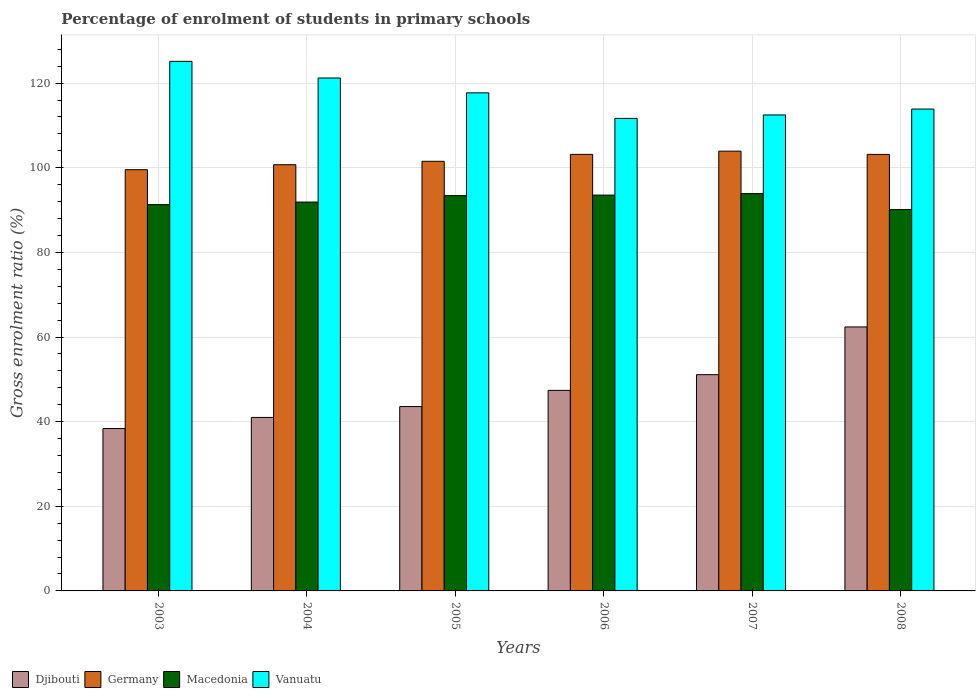How many groups of bars are there?
Your answer should be very brief. 6. Are the number of bars per tick equal to the number of legend labels?
Offer a very short reply. Yes. Are the number of bars on each tick of the X-axis equal?
Provide a short and direct response. Yes. How many bars are there on the 1st tick from the left?
Give a very brief answer. 4. How many bars are there on the 5th tick from the right?
Your response must be concise. 4. In how many cases, is the number of bars for a given year not equal to the number of legend labels?
Your answer should be compact. 0. What is the percentage of students enrolled in primary schools in Djibouti in 2003?
Make the answer very short. 38.37. Across all years, what is the maximum percentage of students enrolled in primary schools in Macedonia?
Provide a succinct answer. 93.9. Across all years, what is the minimum percentage of students enrolled in primary schools in Djibouti?
Give a very brief answer. 38.37. In which year was the percentage of students enrolled in primary schools in Vanuatu minimum?
Your answer should be compact. 2006. What is the total percentage of students enrolled in primary schools in Djibouti in the graph?
Make the answer very short. 283.82. What is the difference between the percentage of students enrolled in primary schools in Vanuatu in 2003 and that in 2008?
Provide a short and direct response. 11.27. What is the difference between the percentage of students enrolled in primary schools in Vanuatu in 2008 and the percentage of students enrolled in primary schools in Macedonia in 2006?
Your answer should be very brief. 20.33. What is the average percentage of students enrolled in primary schools in Germany per year?
Your response must be concise. 102.01. In the year 2003, what is the difference between the percentage of students enrolled in primary schools in Macedonia and percentage of students enrolled in primary schools in Germany?
Give a very brief answer. -8.25. In how many years, is the percentage of students enrolled in primary schools in Djibouti greater than 100 %?
Make the answer very short. 0. What is the ratio of the percentage of students enrolled in primary schools in Vanuatu in 2004 to that in 2005?
Offer a very short reply. 1.03. What is the difference between the highest and the second highest percentage of students enrolled in primary schools in Vanuatu?
Your response must be concise. 3.93. What is the difference between the highest and the lowest percentage of students enrolled in primary schools in Germany?
Ensure brevity in your answer.  4.39. Is it the case that in every year, the sum of the percentage of students enrolled in primary schools in Macedonia and percentage of students enrolled in primary schools in Germany is greater than the sum of percentage of students enrolled in primary schools in Vanuatu and percentage of students enrolled in primary schools in Djibouti?
Offer a terse response. No. What does the 1st bar from the left in 2007 represents?
Your answer should be compact. Djibouti. What does the 1st bar from the right in 2003 represents?
Your answer should be very brief. Vanuatu. How many bars are there?
Your response must be concise. 24. Are all the bars in the graph horizontal?
Keep it short and to the point. No. Does the graph contain any zero values?
Your answer should be very brief. No. Does the graph contain grids?
Your answer should be compact. Yes. How are the legend labels stacked?
Your answer should be compact. Horizontal. What is the title of the graph?
Offer a very short reply. Percentage of enrolment of students in primary schools. What is the Gross enrolment ratio (%) of Djibouti in 2003?
Your answer should be compact. 38.37. What is the Gross enrolment ratio (%) of Germany in 2003?
Provide a succinct answer. 99.54. What is the Gross enrolment ratio (%) of Macedonia in 2003?
Make the answer very short. 91.29. What is the Gross enrolment ratio (%) of Vanuatu in 2003?
Keep it short and to the point. 125.15. What is the Gross enrolment ratio (%) of Djibouti in 2004?
Your answer should be very brief. 41. What is the Gross enrolment ratio (%) in Germany in 2004?
Make the answer very short. 100.72. What is the Gross enrolment ratio (%) in Macedonia in 2004?
Your answer should be compact. 91.9. What is the Gross enrolment ratio (%) of Vanuatu in 2004?
Provide a short and direct response. 121.22. What is the Gross enrolment ratio (%) in Djibouti in 2005?
Provide a short and direct response. 43.57. What is the Gross enrolment ratio (%) of Germany in 2005?
Keep it short and to the point. 101.53. What is the Gross enrolment ratio (%) of Macedonia in 2005?
Offer a terse response. 93.42. What is the Gross enrolment ratio (%) in Vanuatu in 2005?
Provide a short and direct response. 117.71. What is the Gross enrolment ratio (%) in Djibouti in 2006?
Offer a very short reply. 47.39. What is the Gross enrolment ratio (%) in Germany in 2006?
Keep it short and to the point. 103.17. What is the Gross enrolment ratio (%) in Macedonia in 2006?
Offer a terse response. 93.54. What is the Gross enrolment ratio (%) in Vanuatu in 2006?
Ensure brevity in your answer.  111.67. What is the Gross enrolment ratio (%) of Djibouti in 2007?
Keep it short and to the point. 51.1. What is the Gross enrolment ratio (%) of Germany in 2007?
Offer a terse response. 103.93. What is the Gross enrolment ratio (%) of Macedonia in 2007?
Keep it short and to the point. 93.9. What is the Gross enrolment ratio (%) in Vanuatu in 2007?
Your answer should be compact. 112.48. What is the Gross enrolment ratio (%) of Djibouti in 2008?
Your answer should be very brief. 62.38. What is the Gross enrolment ratio (%) in Germany in 2008?
Your answer should be compact. 103.16. What is the Gross enrolment ratio (%) in Macedonia in 2008?
Your answer should be very brief. 90.13. What is the Gross enrolment ratio (%) of Vanuatu in 2008?
Your answer should be compact. 113.87. Across all years, what is the maximum Gross enrolment ratio (%) in Djibouti?
Make the answer very short. 62.38. Across all years, what is the maximum Gross enrolment ratio (%) of Germany?
Your answer should be compact. 103.93. Across all years, what is the maximum Gross enrolment ratio (%) of Macedonia?
Offer a terse response. 93.9. Across all years, what is the maximum Gross enrolment ratio (%) of Vanuatu?
Your answer should be compact. 125.15. Across all years, what is the minimum Gross enrolment ratio (%) in Djibouti?
Your answer should be compact. 38.37. Across all years, what is the minimum Gross enrolment ratio (%) of Germany?
Give a very brief answer. 99.54. Across all years, what is the minimum Gross enrolment ratio (%) of Macedonia?
Keep it short and to the point. 90.13. Across all years, what is the minimum Gross enrolment ratio (%) in Vanuatu?
Ensure brevity in your answer.  111.67. What is the total Gross enrolment ratio (%) in Djibouti in the graph?
Make the answer very short. 283.82. What is the total Gross enrolment ratio (%) in Germany in the graph?
Your answer should be compact. 612.04. What is the total Gross enrolment ratio (%) of Macedonia in the graph?
Ensure brevity in your answer.  554.17. What is the total Gross enrolment ratio (%) in Vanuatu in the graph?
Ensure brevity in your answer.  702.1. What is the difference between the Gross enrolment ratio (%) of Djibouti in 2003 and that in 2004?
Your answer should be compact. -2.63. What is the difference between the Gross enrolment ratio (%) of Germany in 2003 and that in 2004?
Offer a terse response. -1.18. What is the difference between the Gross enrolment ratio (%) in Macedonia in 2003 and that in 2004?
Your answer should be very brief. -0.61. What is the difference between the Gross enrolment ratio (%) of Vanuatu in 2003 and that in 2004?
Give a very brief answer. 3.93. What is the difference between the Gross enrolment ratio (%) in Djibouti in 2003 and that in 2005?
Your answer should be compact. -5.19. What is the difference between the Gross enrolment ratio (%) in Germany in 2003 and that in 2005?
Provide a succinct answer. -1.99. What is the difference between the Gross enrolment ratio (%) of Macedonia in 2003 and that in 2005?
Your answer should be very brief. -2.13. What is the difference between the Gross enrolment ratio (%) in Vanuatu in 2003 and that in 2005?
Give a very brief answer. 7.44. What is the difference between the Gross enrolment ratio (%) of Djibouti in 2003 and that in 2006?
Your answer should be very brief. -9.02. What is the difference between the Gross enrolment ratio (%) in Germany in 2003 and that in 2006?
Offer a very short reply. -3.63. What is the difference between the Gross enrolment ratio (%) in Macedonia in 2003 and that in 2006?
Make the answer very short. -2.25. What is the difference between the Gross enrolment ratio (%) in Vanuatu in 2003 and that in 2006?
Your answer should be compact. 13.48. What is the difference between the Gross enrolment ratio (%) in Djibouti in 2003 and that in 2007?
Provide a short and direct response. -12.73. What is the difference between the Gross enrolment ratio (%) of Germany in 2003 and that in 2007?
Your answer should be very brief. -4.39. What is the difference between the Gross enrolment ratio (%) of Macedonia in 2003 and that in 2007?
Provide a short and direct response. -2.61. What is the difference between the Gross enrolment ratio (%) of Vanuatu in 2003 and that in 2007?
Offer a very short reply. 12.66. What is the difference between the Gross enrolment ratio (%) of Djibouti in 2003 and that in 2008?
Your response must be concise. -24.01. What is the difference between the Gross enrolment ratio (%) of Germany in 2003 and that in 2008?
Offer a terse response. -3.62. What is the difference between the Gross enrolment ratio (%) in Macedonia in 2003 and that in 2008?
Offer a very short reply. 1.16. What is the difference between the Gross enrolment ratio (%) in Vanuatu in 2003 and that in 2008?
Your answer should be compact. 11.27. What is the difference between the Gross enrolment ratio (%) in Djibouti in 2004 and that in 2005?
Give a very brief answer. -2.57. What is the difference between the Gross enrolment ratio (%) in Germany in 2004 and that in 2005?
Ensure brevity in your answer.  -0.81. What is the difference between the Gross enrolment ratio (%) of Macedonia in 2004 and that in 2005?
Offer a very short reply. -1.52. What is the difference between the Gross enrolment ratio (%) of Vanuatu in 2004 and that in 2005?
Offer a terse response. 3.51. What is the difference between the Gross enrolment ratio (%) of Djibouti in 2004 and that in 2006?
Your answer should be very brief. -6.39. What is the difference between the Gross enrolment ratio (%) of Germany in 2004 and that in 2006?
Your answer should be very brief. -2.45. What is the difference between the Gross enrolment ratio (%) of Macedonia in 2004 and that in 2006?
Provide a succinct answer. -1.64. What is the difference between the Gross enrolment ratio (%) in Vanuatu in 2004 and that in 2006?
Provide a succinct answer. 9.55. What is the difference between the Gross enrolment ratio (%) in Djibouti in 2004 and that in 2007?
Give a very brief answer. -10.1. What is the difference between the Gross enrolment ratio (%) in Germany in 2004 and that in 2007?
Provide a short and direct response. -3.21. What is the difference between the Gross enrolment ratio (%) in Macedonia in 2004 and that in 2007?
Your answer should be very brief. -2. What is the difference between the Gross enrolment ratio (%) of Vanuatu in 2004 and that in 2007?
Make the answer very short. 8.73. What is the difference between the Gross enrolment ratio (%) of Djibouti in 2004 and that in 2008?
Ensure brevity in your answer.  -21.38. What is the difference between the Gross enrolment ratio (%) in Germany in 2004 and that in 2008?
Ensure brevity in your answer.  -2.44. What is the difference between the Gross enrolment ratio (%) in Macedonia in 2004 and that in 2008?
Give a very brief answer. 1.77. What is the difference between the Gross enrolment ratio (%) in Vanuatu in 2004 and that in 2008?
Keep it short and to the point. 7.34. What is the difference between the Gross enrolment ratio (%) in Djibouti in 2005 and that in 2006?
Your response must be concise. -3.83. What is the difference between the Gross enrolment ratio (%) of Germany in 2005 and that in 2006?
Give a very brief answer. -1.64. What is the difference between the Gross enrolment ratio (%) of Macedonia in 2005 and that in 2006?
Your answer should be compact. -0.13. What is the difference between the Gross enrolment ratio (%) in Vanuatu in 2005 and that in 2006?
Provide a short and direct response. 6.04. What is the difference between the Gross enrolment ratio (%) in Djibouti in 2005 and that in 2007?
Your answer should be very brief. -7.54. What is the difference between the Gross enrolment ratio (%) of Germany in 2005 and that in 2007?
Your answer should be compact. -2.4. What is the difference between the Gross enrolment ratio (%) in Macedonia in 2005 and that in 2007?
Your answer should be very brief. -0.48. What is the difference between the Gross enrolment ratio (%) of Vanuatu in 2005 and that in 2007?
Provide a succinct answer. 5.22. What is the difference between the Gross enrolment ratio (%) in Djibouti in 2005 and that in 2008?
Ensure brevity in your answer.  -18.82. What is the difference between the Gross enrolment ratio (%) of Germany in 2005 and that in 2008?
Offer a terse response. -1.63. What is the difference between the Gross enrolment ratio (%) of Macedonia in 2005 and that in 2008?
Give a very brief answer. 3.29. What is the difference between the Gross enrolment ratio (%) in Vanuatu in 2005 and that in 2008?
Give a very brief answer. 3.83. What is the difference between the Gross enrolment ratio (%) of Djibouti in 2006 and that in 2007?
Provide a short and direct response. -3.71. What is the difference between the Gross enrolment ratio (%) in Germany in 2006 and that in 2007?
Ensure brevity in your answer.  -0.76. What is the difference between the Gross enrolment ratio (%) of Macedonia in 2006 and that in 2007?
Provide a succinct answer. -0.35. What is the difference between the Gross enrolment ratio (%) of Vanuatu in 2006 and that in 2007?
Keep it short and to the point. -0.82. What is the difference between the Gross enrolment ratio (%) of Djibouti in 2006 and that in 2008?
Your answer should be compact. -14.99. What is the difference between the Gross enrolment ratio (%) of Germany in 2006 and that in 2008?
Keep it short and to the point. 0.01. What is the difference between the Gross enrolment ratio (%) of Macedonia in 2006 and that in 2008?
Ensure brevity in your answer.  3.42. What is the difference between the Gross enrolment ratio (%) of Vanuatu in 2006 and that in 2008?
Provide a succinct answer. -2.21. What is the difference between the Gross enrolment ratio (%) of Djibouti in 2007 and that in 2008?
Ensure brevity in your answer.  -11.28. What is the difference between the Gross enrolment ratio (%) in Germany in 2007 and that in 2008?
Offer a terse response. 0.77. What is the difference between the Gross enrolment ratio (%) in Macedonia in 2007 and that in 2008?
Keep it short and to the point. 3.77. What is the difference between the Gross enrolment ratio (%) of Vanuatu in 2007 and that in 2008?
Offer a very short reply. -1.39. What is the difference between the Gross enrolment ratio (%) of Djibouti in 2003 and the Gross enrolment ratio (%) of Germany in 2004?
Your response must be concise. -62.35. What is the difference between the Gross enrolment ratio (%) of Djibouti in 2003 and the Gross enrolment ratio (%) of Macedonia in 2004?
Your answer should be compact. -53.53. What is the difference between the Gross enrolment ratio (%) of Djibouti in 2003 and the Gross enrolment ratio (%) of Vanuatu in 2004?
Provide a succinct answer. -82.84. What is the difference between the Gross enrolment ratio (%) in Germany in 2003 and the Gross enrolment ratio (%) in Macedonia in 2004?
Offer a terse response. 7.64. What is the difference between the Gross enrolment ratio (%) of Germany in 2003 and the Gross enrolment ratio (%) of Vanuatu in 2004?
Your answer should be very brief. -21.68. What is the difference between the Gross enrolment ratio (%) of Macedonia in 2003 and the Gross enrolment ratio (%) of Vanuatu in 2004?
Offer a very short reply. -29.93. What is the difference between the Gross enrolment ratio (%) in Djibouti in 2003 and the Gross enrolment ratio (%) in Germany in 2005?
Offer a very short reply. -63.15. What is the difference between the Gross enrolment ratio (%) of Djibouti in 2003 and the Gross enrolment ratio (%) of Macedonia in 2005?
Your answer should be compact. -55.04. What is the difference between the Gross enrolment ratio (%) in Djibouti in 2003 and the Gross enrolment ratio (%) in Vanuatu in 2005?
Your response must be concise. -79.33. What is the difference between the Gross enrolment ratio (%) of Germany in 2003 and the Gross enrolment ratio (%) of Macedonia in 2005?
Make the answer very short. 6.12. What is the difference between the Gross enrolment ratio (%) in Germany in 2003 and the Gross enrolment ratio (%) in Vanuatu in 2005?
Keep it short and to the point. -18.17. What is the difference between the Gross enrolment ratio (%) of Macedonia in 2003 and the Gross enrolment ratio (%) of Vanuatu in 2005?
Provide a short and direct response. -26.42. What is the difference between the Gross enrolment ratio (%) in Djibouti in 2003 and the Gross enrolment ratio (%) in Germany in 2006?
Ensure brevity in your answer.  -64.79. What is the difference between the Gross enrolment ratio (%) of Djibouti in 2003 and the Gross enrolment ratio (%) of Macedonia in 2006?
Ensure brevity in your answer.  -55.17. What is the difference between the Gross enrolment ratio (%) in Djibouti in 2003 and the Gross enrolment ratio (%) in Vanuatu in 2006?
Give a very brief answer. -73.29. What is the difference between the Gross enrolment ratio (%) of Germany in 2003 and the Gross enrolment ratio (%) of Macedonia in 2006?
Offer a very short reply. 6. What is the difference between the Gross enrolment ratio (%) of Germany in 2003 and the Gross enrolment ratio (%) of Vanuatu in 2006?
Your answer should be compact. -12.13. What is the difference between the Gross enrolment ratio (%) of Macedonia in 2003 and the Gross enrolment ratio (%) of Vanuatu in 2006?
Keep it short and to the point. -20.38. What is the difference between the Gross enrolment ratio (%) in Djibouti in 2003 and the Gross enrolment ratio (%) in Germany in 2007?
Provide a succinct answer. -65.55. What is the difference between the Gross enrolment ratio (%) of Djibouti in 2003 and the Gross enrolment ratio (%) of Macedonia in 2007?
Your response must be concise. -55.52. What is the difference between the Gross enrolment ratio (%) in Djibouti in 2003 and the Gross enrolment ratio (%) in Vanuatu in 2007?
Your answer should be very brief. -74.11. What is the difference between the Gross enrolment ratio (%) of Germany in 2003 and the Gross enrolment ratio (%) of Macedonia in 2007?
Provide a short and direct response. 5.64. What is the difference between the Gross enrolment ratio (%) in Germany in 2003 and the Gross enrolment ratio (%) in Vanuatu in 2007?
Offer a very short reply. -12.94. What is the difference between the Gross enrolment ratio (%) in Macedonia in 2003 and the Gross enrolment ratio (%) in Vanuatu in 2007?
Give a very brief answer. -21.2. What is the difference between the Gross enrolment ratio (%) in Djibouti in 2003 and the Gross enrolment ratio (%) in Germany in 2008?
Make the answer very short. -64.79. What is the difference between the Gross enrolment ratio (%) of Djibouti in 2003 and the Gross enrolment ratio (%) of Macedonia in 2008?
Your response must be concise. -51.75. What is the difference between the Gross enrolment ratio (%) of Djibouti in 2003 and the Gross enrolment ratio (%) of Vanuatu in 2008?
Your response must be concise. -75.5. What is the difference between the Gross enrolment ratio (%) in Germany in 2003 and the Gross enrolment ratio (%) in Macedonia in 2008?
Make the answer very short. 9.41. What is the difference between the Gross enrolment ratio (%) of Germany in 2003 and the Gross enrolment ratio (%) of Vanuatu in 2008?
Keep it short and to the point. -14.33. What is the difference between the Gross enrolment ratio (%) of Macedonia in 2003 and the Gross enrolment ratio (%) of Vanuatu in 2008?
Provide a succinct answer. -22.59. What is the difference between the Gross enrolment ratio (%) of Djibouti in 2004 and the Gross enrolment ratio (%) of Germany in 2005?
Offer a very short reply. -60.53. What is the difference between the Gross enrolment ratio (%) in Djibouti in 2004 and the Gross enrolment ratio (%) in Macedonia in 2005?
Provide a short and direct response. -52.42. What is the difference between the Gross enrolment ratio (%) in Djibouti in 2004 and the Gross enrolment ratio (%) in Vanuatu in 2005?
Make the answer very short. -76.71. What is the difference between the Gross enrolment ratio (%) in Germany in 2004 and the Gross enrolment ratio (%) in Macedonia in 2005?
Give a very brief answer. 7.3. What is the difference between the Gross enrolment ratio (%) of Germany in 2004 and the Gross enrolment ratio (%) of Vanuatu in 2005?
Give a very brief answer. -16.99. What is the difference between the Gross enrolment ratio (%) in Macedonia in 2004 and the Gross enrolment ratio (%) in Vanuatu in 2005?
Provide a short and direct response. -25.81. What is the difference between the Gross enrolment ratio (%) of Djibouti in 2004 and the Gross enrolment ratio (%) of Germany in 2006?
Provide a succinct answer. -62.17. What is the difference between the Gross enrolment ratio (%) in Djibouti in 2004 and the Gross enrolment ratio (%) in Macedonia in 2006?
Offer a terse response. -52.54. What is the difference between the Gross enrolment ratio (%) of Djibouti in 2004 and the Gross enrolment ratio (%) of Vanuatu in 2006?
Your answer should be compact. -70.67. What is the difference between the Gross enrolment ratio (%) in Germany in 2004 and the Gross enrolment ratio (%) in Macedonia in 2006?
Offer a terse response. 7.18. What is the difference between the Gross enrolment ratio (%) in Germany in 2004 and the Gross enrolment ratio (%) in Vanuatu in 2006?
Keep it short and to the point. -10.95. What is the difference between the Gross enrolment ratio (%) of Macedonia in 2004 and the Gross enrolment ratio (%) of Vanuatu in 2006?
Your response must be concise. -19.77. What is the difference between the Gross enrolment ratio (%) in Djibouti in 2004 and the Gross enrolment ratio (%) in Germany in 2007?
Provide a short and direct response. -62.93. What is the difference between the Gross enrolment ratio (%) of Djibouti in 2004 and the Gross enrolment ratio (%) of Macedonia in 2007?
Offer a terse response. -52.9. What is the difference between the Gross enrolment ratio (%) in Djibouti in 2004 and the Gross enrolment ratio (%) in Vanuatu in 2007?
Your answer should be very brief. -71.48. What is the difference between the Gross enrolment ratio (%) of Germany in 2004 and the Gross enrolment ratio (%) of Macedonia in 2007?
Provide a short and direct response. 6.82. What is the difference between the Gross enrolment ratio (%) in Germany in 2004 and the Gross enrolment ratio (%) in Vanuatu in 2007?
Your response must be concise. -11.76. What is the difference between the Gross enrolment ratio (%) of Macedonia in 2004 and the Gross enrolment ratio (%) of Vanuatu in 2007?
Your answer should be compact. -20.59. What is the difference between the Gross enrolment ratio (%) of Djibouti in 2004 and the Gross enrolment ratio (%) of Germany in 2008?
Make the answer very short. -62.16. What is the difference between the Gross enrolment ratio (%) of Djibouti in 2004 and the Gross enrolment ratio (%) of Macedonia in 2008?
Your answer should be very brief. -49.13. What is the difference between the Gross enrolment ratio (%) of Djibouti in 2004 and the Gross enrolment ratio (%) of Vanuatu in 2008?
Keep it short and to the point. -72.87. What is the difference between the Gross enrolment ratio (%) in Germany in 2004 and the Gross enrolment ratio (%) in Macedonia in 2008?
Make the answer very short. 10.59. What is the difference between the Gross enrolment ratio (%) of Germany in 2004 and the Gross enrolment ratio (%) of Vanuatu in 2008?
Make the answer very short. -13.15. What is the difference between the Gross enrolment ratio (%) in Macedonia in 2004 and the Gross enrolment ratio (%) in Vanuatu in 2008?
Provide a short and direct response. -21.98. What is the difference between the Gross enrolment ratio (%) in Djibouti in 2005 and the Gross enrolment ratio (%) in Germany in 2006?
Your answer should be very brief. -59.6. What is the difference between the Gross enrolment ratio (%) in Djibouti in 2005 and the Gross enrolment ratio (%) in Macedonia in 2006?
Offer a very short reply. -49.98. What is the difference between the Gross enrolment ratio (%) in Djibouti in 2005 and the Gross enrolment ratio (%) in Vanuatu in 2006?
Make the answer very short. -68.1. What is the difference between the Gross enrolment ratio (%) of Germany in 2005 and the Gross enrolment ratio (%) of Macedonia in 2006?
Your response must be concise. 7.99. What is the difference between the Gross enrolment ratio (%) in Germany in 2005 and the Gross enrolment ratio (%) in Vanuatu in 2006?
Make the answer very short. -10.14. What is the difference between the Gross enrolment ratio (%) in Macedonia in 2005 and the Gross enrolment ratio (%) in Vanuatu in 2006?
Provide a succinct answer. -18.25. What is the difference between the Gross enrolment ratio (%) in Djibouti in 2005 and the Gross enrolment ratio (%) in Germany in 2007?
Ensure brevity in your answer.  -60.36. What is the difference between the Gross enrolment ratio (%) in Djibouti in 2005 and the Gross enrolment ratio (%) in Macedonia in 2007?
Keep it short and to the point. -50.33. What is the difference between the Gross enrolment ratio (%) in Djibouti in 2005 and the Gross enrolment ratio (%) in Vanuatu in 2007?
Keep it short and to the point. -68.92. What is the difference between the Gross enrolment ratio (%) of Germany in 2005 and the Gross enrolment ratio (%) of Macedonia in 2007?
Keep it short and to the point. 7.63. What is the difference between the Gross enrolment ratio (%) of Germany in 2005 and the Gross enrolment ratio (%) of Vanuatu in 2007?
Offer a terse response. -10.96. What is the difference between the Gross enrolment ratio (%) of Macedonia in 2005 and the Gross enrolment ratio (%) of Vanuatu in 2007?
Your response must be concise. -19.07. What is the difference between the Gross enrolment ratio (%) of Djibouti in 2005 and the Gross enrolment ratio (%) of Germany in 2008?
Offer a very short reply. -59.59. What is the difference between the Gross enrolment ratio (%) in Djibouti in 2005 and the Gross enrolment ratio (%) in Macedonia in 2008?
Your answer should be compact. -46.56. What is the difference between the Gross enrolment ratio (%) of Djibouti in 2005 and the Gross enrolment ratio (%) of Vanuatu in 2008?
Offer a very short reply. -70.31. What is the difference between the Gross enrolment ratio (%) of Germany in 2005 and the Gross enrolment ratio (%) of Macedonia in 2008?
Offer a terse response. 11.4. What is the difference between the Gross enrolment ratio (%) of Germany in 2005 and the Gross enrolment ratio (%) of Vanuatu in 2008?
Give a very brief answer. -12.35. What is the difference between the Gross enrolment ratio (%) of Macedonia in 2005 and the Gross enrolment ratio (%) of Vanuatu in 2008?
Provide a short and direct response. -20.46. What is the difference between the Gross enrolment ratio (%) of Djibouti in 2006 and the Gross enrolment ratio (%) of Germany in 2007?
Give a very brief answer. -56.53. What is the difference between the Gross enrolment ratio (%) of Djibouti in 2006 and the Gross enrolment ratio (%) of Macedonia in 2007?
Keep it short and to the point. -46.5. What is the difference between the Gross enrolment ratio (%) in Djibouti in 2006 and the Gross enrolment ratio (%) in Vanuatu in 2007?
Provide a succinct answer. -65.09. What is the difference between the Gross enrolment ratio (%) of Germany in 2006 and the Gross enrolment ratio (%) of Macedonia in 2007?
Offer a terse response. 9.27. What is the difference between the Gross enrolment ratio (%) in Germany in 2006 and the Gross enrolment ratio (%) in Vanuatu in 2007?
Keep it short and to the point. -9.32. What is the difference between the Gross enrolment ratio (%) in Macedonia in 2006 and the Gross enrolment ratio (%) in Vanuatu in 2007?
Your answer should be compact. -18.94. What is the difference between the Gross enrolment ratio (%) of Djibouti in 2006 and the Gross enrolment ratio (%) of Germany in 2008?
Offer a terse response. -55.77. What is the difference between the Gross enrolment ratio (%) of Djibouti in 2006 and the Gross enrolment ratio (%) of Macedonia in 2008?
Your answer should be very brief. -42.73. What is the difference between the Gross enrolment ratio (%) of Djibouti in 2006 and the Gross enrolment ratio (%) of Vanuatu in 2008?
Offer a terse response. -66.48. What is the difference between the Gross enrolment ratio (%) in Germany in 2006 and the Gross enrolment ratio (%) in Macedonia in 2008?
Keep it short and to the point. 13.04. What is the difference between the Gross enrolment ratio (%) in Germany in 2006 and the Gross enrolment ratio (%) in Vanuatu in 2008?
Offer a terse response. -10.71. What is the difference between the Gross enrolment ratio (%) of Macedonia in 2006 and the Gross enrolment ratio (%) of Vanuatu in 2008?
Provide a short and direct response. -20.33. What is the difference between the Gross enrolment ratio (%) of Djibouti in 2007 and the Gross enrolment ratio (%) of Germany in 2008?
Give a very brief answer. -52.06. What is the difference between the Gross enrolment ratio (%) of Djibouti in 2007 and the Gross enrolment ratio (%) of Macedonia in 2008?
Keep it short and to the point. -39.02. What is the difference between the Gross enrolment ratio (%) in Djibouti in 2007 and the Gross enrolment ratio (%) in Vanuatu in 2008?
Your answer should be very brief. -62.77. What is the difference between the Gross enrolment ratio (%) in Germany in 2007 and the Gross enrolment ratio (%) in Macedonia in 2008?
Ensure brevity in your answer.  13.8. What is the difference between the Gross enrolment ratio (%) in Germany in 2007 and the Gross enrolment ratio (%) in Vanuatu in 2008?
Offer a terse response. -9.95. What is the difference between the Gross enrolment ratio (%) in Macedonia in 2007 and the Gross enrolment ratio (%) in Vanuatu in 2008?
Provide a succinct answer. -19.98. What is the average Gross enrolment ratio (%) in Djibouti per year?
Ensure brevity in your answer.  47.3. What is the average Gross enrolment ratio (%) of Germany per year?
Ensure brevity in your answer.  102.01. What is the average Gross enrolment ratio (%) in Macedonia per year?
Your answer should be compact. 92.36. What is the average Gross enrolment ratio (%) of Vanuatu per year?
Offer a very short reply. 117.02. In the year 2003, what is the difference between the Gross enrolment ratio (%) of Djibouti and Gross enrolment ratio (%) of Germany?
Offer a terse response. -61.17. In the year 2003, what is the difference between the Gross enrolment ratio (%) in Djibouti and Gross enrolment ratio (%) in Macedonia?
Offer a very short reply. -52.92. In the year 2003, what is the difference between the Gross enrolment ratio (%) of Djibouti and Gross enrolment ratio (%) of Vanuatu?
Your answer should be compact. -86.78. In the year 2003, what is the difference between the Gross enrolment ratio (%) in Germany and Gross enrolment ratio (%) in Macedonia?
Make the answer very short. 8.25. In the year 2003, what is the difference between the Gross enrolment ratio (%) in Germany and Gross enrolment ratio (%) in Vanuatu?
Keep it short and to the point. -25.61. In the year 2003, what is the difference between the Gross enrolment ratio (%) in Macedonia and Gross enrolment ratio (%) in Vanuatu?
Give a very brief answer. -33.86. In the year 2004, what is the difference between the Gross enrolment ratio (%) in Djibouti and Gross enrolment ratio (%) in Germany?
Your response must be concise. -59.72. In the year 2004, what is the difference between the Gross enrolment ratio (%) of Djibouti and Gross enrolment ratio (%) of Macedonia?
Offer a very short reply. -50.9. In the year 2004, what is the difference between the Gross enrolment ratio (%) of Djibouti and Gross enrolment ratio (%) of Vanuatu?
Provide a short and direct response. -80.22. In the year 2004, what is the difference between the Gross enrolment ratio (%) in Germany and Gross enrolment ratio (%) in Macedonia?
Provide a short and direct response. 8.82. In the year 2004, what is the difference between the Gross enrolment ratio (%) in Germany and Gross enrolment ratio (%) in Vanuatu?
Offer a terse response. -20.5. In the year 2004, what is the difference between the Gross enrolment ratio (%) in Macedonia and Gross enrolment ratio (%) in Vanuatu?
Your answer should be very brief. -29.32. In the year 2005, what is the difference between the Gross enrolment ratio (%) of Djibouti and Gross enrolment ratio (%) of Germany?
Your response must be concise. -57.96. In the year 2005, what is the difference between the Gross enrolment ratio (%) of Djibouti and Gross enrolment ratio (%) of Macedonia?
Offer a very short reply. -49.85. In the year 2005, what is the difference between the Gross enrolment ratio (%) in Djibouti and Gross enrolment ratio (%) in Vanuatu?
Keep it short and to the point. -74.14. In the year 2005, what is the difference between the Gross enrolment ratio (%) of Germany and Gross enrolment ratio (%) of Macedonia?
Your answer should be very brief. 8.11. In the year 2005, what is the difference between the Gross enrolment ratio (%) of Germany and Gross enrolment ratio (%) of Vanuatu?
Offer a very short reply. -16.18. In the year 2005, what is the difference between the Gross enrolment ratio (%) of Macedonia and Gross enrolment ratio (%) of Vanuatu?
Offer a very short reply. -24.29. In the year 2006, what is the difference between the Gross enrolment ratio (%) of Djibouti and Gross enrolment ratio (%) of Germany?
Your answer should be very brief. -55.77. In the year 2006, what is the difference between the Gross enrolment ratio (%) in Djibouti and Gross enrolment ratio (%) in Macedonia?
Offer a very short reply. -46.15. In the year 2006, what is the difference between the Gross enrolment ratio (%) in Djibouti and Gross enrolment ratio (%) in Vanuatu?
Your answer should be compact. -64.27. In the year 2006, what is the difference between the Gross enrolment ratio (%) of Germany and Gross enrolment ratio (%) of Macedonia?
Provide a succinct answer. 9.62. In the year 2006, what is the difference between the Gross enrolment ratio (%) of Germany and Gross enrolment ratio (%) of Vanuatu?
Give a very brief answer. -8.5. In the year 2006, what is the difference between the Gross enrolment ratio (%) of Macedonia and Gross enrolment ratio (%) of Vanuatu?
Your response must be concise. -18.12. In the year 2007, what is the difference between the Gross enrolment ratio (%) in Djibouti and Gross enrolment ratio (%) in Germany?
Your answer should be compact. -52.82. In the year 2007, what is the difference between the Gross enrolment ratio (%) of Djibouti and Gross enrolment ratio (%) of Macedonia?
Offer a very short reply. -42.79. In the year 2007, what is the difference between the Gross enrolment ratio (%) of Djibouti and Gross enrolment ratio (%) of Vanuatu?
Your answer should be compact. -61.38. In the year 2007, what is the difference between the Gross enrolment ratio (%) in Germany and Gross enrolment ratio (%) in Macedonia?
Ensure brevity in your answer.  10.03. In the year 2007, what is the difference between the Gross enrolment ratio (%) of Germany and Gross enrolment ratio (%) of Vanuatu?
Provide a short and direct response. -8.56. In the year 2007, what is the difference between the Gross enrolment ratio (%) in Macedonia and Gross enrolment ratio (%) in Vanuatu?
Provide a succinct answer. -18.59. In the year 2008, what is the difference between the Gross enrolment ratio (%) of Djibouti and Gross enrolment ratio (%) of Germany?
Offer a terse response. -40.78. In the year 2008, what is the difference between the Gross enrolment ratio (%) in Djibouti and Gross enrolment ratio (%) in Macedonia?
Offer a very short reply. -27.74. In the year 2008, what is the difference between the Gross enrolment ratio (%) of Djibouti and Gross enrolment ratio (%) of Vanuatu?
Make the answer very short. -51.49. In the year 2008, what is the difference between the Gross enrolment ratio (%) of Germany and Gross enrolment ratio (%) of Macedonia?
Provide a succinct answer. 13.03. In the year 2008, what is the difference between the Gross enrolment ratio (%) of Germany and Gross enrolment ratio (%) of Vanuatu?
Your answer should be very brief. -10.71. In the year 2008, what is the difference between the Gross enrolment ratio (%) in Macedonia and Gross enrolment ratio (%) in Vanuatu?
Ensure brevity in your answer.  -23.75. What is the ratio of the Gross enrolment ratio (%) in Djibouti in 2003 to that in 2004?
Offer a terse response. 0.94. What is the ratio of the Gross enrolment ratio (%) in Germany in 2003 to that in 2004?
Offer a very short reply. 0.99. What is the ratio of the Gross enrolment ratio (%) of Macedonia in 2003 to that in 2004?
Make the answer very short. 0.99. What is the ratio of the Gross enrolment ratio (%) in Vanuatu in 2003 to that in 2004?
Provide a succinct answer. 1.03. What is the ratio of the Gross enrolment ratio (%) of Djibouti in 2003 to that in 2005?
Your answer should be compact. 0.88. What is the ratio of the Gross enrolment ratio (%) of Germany in 2003 to that in 2005?
Your answer should be compact. 0.98. What is the ratio of the Gross enrolment ratio (%) of Macedonia in 2003 to that in 2005?
Offer a terse response. 0.98. What is the ratio of the Gross enrolment ratio (%) in Vanuatu in 2003 to that in 2005?
Your response must be concise. 1.06. What is the ratio of the Gross enrolment ratio (%) of Djibouti in 2003 to that in 2006?
Your answer should be very brief. 0.81. What is the ratio of the Gross enrolment ratio (%) of Germany in 2003 to that in 2006?
Keep it short and to the point. 0.96. What is the ratio of the Gross enrolment ratio (%) of Macedonia in 2003 to that in 2006?
Offer a very short reply. 0.98. What is the ratio of the Gross enrolment ratio (%) in Vanuatu in 2003 to that in 2006?
Your answer should be very brief. 1.12. What is the ratio of the Gross enrolment ratio (%) of Djibouti in 2003 to that in 2007?
Your answer should be compact. 0.75. What is the ratio of the Gross enrolment ratio (%) of Germany in 2003 to that in 2007?
Your response must be concise. 0.96. What is the ratio of the Gross enrolment ratio (%) of Macedonia in 2003 to that in 2007?
Offer a very short reply. 0.97. What is the ratio of the Gross enrolment ratio (%) of Vanuatu in 2003 to that in 2007?
Offer a terse response. 1.11. What is the ratio of the Gross enrolment ratio (%) in Djibouti in 2003 to that in 2008?
Provide a succinct answer. 0.62. What is the ratio of the Gross enrolment ratio (%) of Germany in 2003 to that in 2008?
Offer a very short reply. 0.96. What is the ratio of the Gross enrolment ratio (%) in Macedonia in 2003 to that in 2008?
Make the answer very short. 1.01. What is the ratio of the Gross enrolment ratio (%) of Vanuatu in 2003 to that in 2008?
Your answer should be compact. 1.1. What is the ratio of the Gross enrolment ratio (%) of Djibouti in 2004 to that in 2005?
Your answer should be very brief. 0.94. What is the ratio of the Gross enrolment ratio (%) in Macedonia in 2004 to that in 2005?
Provide a short and direct response. 0.98. What is the ratio of the Gross enrolment ratio (%) of Vanuatu in 2004 to that in 2005?
Keep it short and to the point. 1.03. What is the ratio of the Gross enrolment ratio (%) of Djibouti in 2004 to that in 2006?
Make the answer very short. 0.87. What is the ratio of the Gross enrolment ratio (%) of Germany in 2004 to that in 2006?
Offer a terse response. 0.98. What is the ratio of the Gross enrolment ratio (%) of Macedonia in 2004 to that in 2006?
Provide a short and direct response. 0.98. What is the ratio of the Gross enrolment ratio (%) of Vanuatu in 2004 to that in 2006?
Give a very brief answer. 1.09. What is the ratio of the Gross enrolment ratio (%) in Djibouti in 2004 to that in 2007?
Offer a very short reply. 0.8. What is the ratio of the Gross enrolment ratio (%) in Germany in 2004 to that in 2007?
Your answer should be very brief. 0.97. What is the ratio of the Gross enrolment ratio (%) in Macedonia in 2004 to that in 2007?
Offer a very short reply. 0.98. What is the ratio of the Gross enrolment ratio (%) of Vanuatu in 2004 to that in 2007?
Offer a terse response. 1.08. What is the ratio of the Gross enrolment ratio (%) of Djibouti in 2004 to that in 2008?
Your response must be concise. 0.66. What is the ratio of the Gross enrolment ratio (%) in Germany in 2004 to that in 2008?
Ensure brevity in your answer.  0.98. What is the ratio of the Gross enrolment ratio (%) in Macedonia in 2004 to that in 2008?
Your response must be concise. 1.02. What is the ratio of the Gross enrolment ratio (%) of Vanuatu in 2004 to that in 2008?
Give a very brief answer. 1.06. What is the ratio of the Gross enrolment ratio (%) in Djibouti in 2005 to that in 2006?
Keep it short and to the point. 0.92. What is the ratio of the Gross enrolment ratio (%) in Germany in 2005 to that in 2006?
Your response must be concise. 0.98. What is the ratio of the Gross enrolment ratio (%) of Vanuatu in 2005 to that in 2006?
Provide a short and direct response. 1.05. What is the ratio of the Gross enrolment ratio (%) of Djibouti in 2005 to that in 2007?
Give a very brief answer. 0.85. What is the ratio of the Gross enrolment ratio (%) in Germany in 2005 to that in 2007?
Provide a succinct answer. 0.98. What is the ratio of the Gross enrolment ratio (%) in Macedonia in 2005 to that in 2007?
Offer a terse response. 0.99. What is the ratio of the Gross enrolment ratio (%) of Vanuatu in 2005 to that in 2007?
Your answer should be compact. 1.05. What is the ratio of the Gross enrolment ratio (%) in Djibouti in 2005 to that in 2008?
Provide a short and direct response. 0.7. What is the ratio of the Gross enrolment ratio (%) in Germany in 2005 to that in 2008?
Make the answer very short. 0.98. What is the ratio of the Gross enrolment ratio (%) in Macedonia in 2005 to that in 2008?
Your answer should be very brief. 1.04. What is the ratio of the Gross enrolment ratio (%) in Vanuatu in 2005 to that in 2008?
Offer a very short reply. 1.03. What is the ratio of the Gross enrolment ratio (%) of Djibouti in 2006 to that in 2007?
Offer a terse response. 0.93. What is the ratio of the Gross enrolment ratio (%) of Germany in 2006 to that in 2007?
Offer a terse response. 0.99. What is the ratio of the Gross enrolment ratio (%) in Vanuatu in 2006 to that in 2007?
Your response must be concise. 0.99. What is the ratio of the Gross enrolment ratio (%) in Djibouti in 2006 to that in 2008?
Make the answer very short. 0.76. What is the ratio of the Gross enrolment ratio (%) in Germany in 2006 to that in 2008?
Provide a succinct answer. 1. What is the ratio of the Gross enrolment ratio (%) in Macedonia in 2006 to that in 2008?
Offer a terse response. 1.04. What is the ratio of the Gross enrolment ratio (%) in Vanuatu in 2006 to that in 2008?
Make the answer very short. 0.98. What is the ratio of the Gross enrolment ratio (%) in Djibouti in 2007 to that in 2008?
Offer a very short reply. 0.82. What is the ratio of the Gross enrolment ratio (%) in Germany in 2007 to that in 2008?
Offer a terse response. 1.01. What is the ratio of the Gross enrolment ratio (%) of Macedonia in 2007 to that in 2008?
Offer a very short reply. 1.04. What is the difference between the highest and the second highest Gross enrolment ratio (%) in Djibouti?
Keep it short and to the point. 11.28. What is the difference between the highest and the second highest Gross enrolment ratio (%) of Germany?
Ensure brevity in your answer.  0.76. What is the difference between the highest and the second highest Gross enrolment ratio (%) of Macedonia?
Make the answer very short. 0.35. What is the difference between the highest and the second highest Gross enrolment ratio (%) in Vanuatu?
Provide a succinct answer. 3.93. What is the difference between the highest and the lowest Gross enrolment ratio (%) of Djibouti?
Provide a short and direct response. 24.01. What is the difference between the highest and the lowest Gross enrolment ratio (%) of Germany?
Your response must be concise. 4.39. What is the difference between the highest and the lowest Gross enrolment ratio (%) in Macedonia?
Your response must be concise. 3.77. What is the difference between the highest and the lowest Gross enrolment ratio (%) of Vanuatu?
Ensure brevity in your answer.  13.48. 